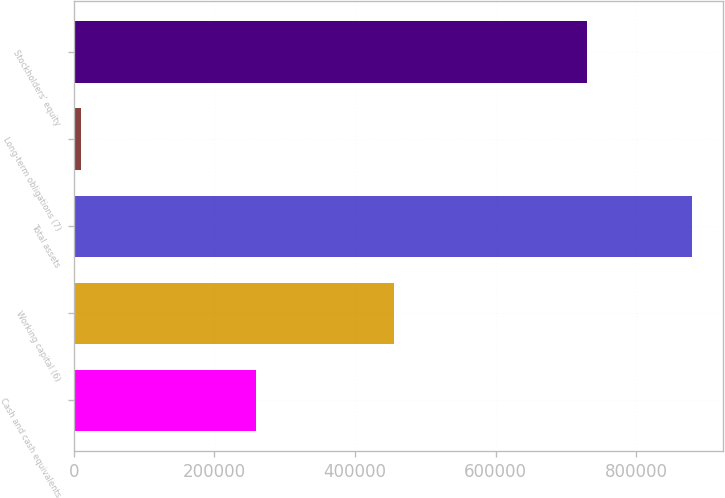Convert chart. <chart><loc_0><loc_0><loc_500><loc_500><bar_chart><fcel>Cash and cash equivalents<fcel>Working capital (6)<fcel>Total assets<fcel>Long-term obligations (7)<fcel>Stockholders' equity<nl><fcel>258598<fcel>455143<fcel>878864<fcel>10191<fcel>730032<nl></chart> 